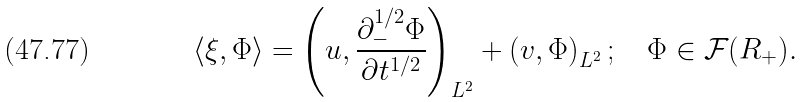<formula> <loc_0><loc_0><loc_500><loc_500>\langle \xi , \Phi \rangle = \left ( u , \frac { \partial _ { - } ^ { 1 / 2 } \Phi } { \partial t ^ { 1 / 2 } } \right ) _ { L ^ { 2 } } + \left ( v , \Phi \right ) _ { L ^ { 2 } } ; \quad \Phi \in \mathcal { F } ( { R } _ { + } ) .</formula> 